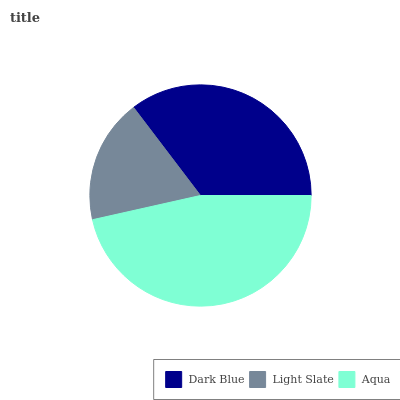Is Light Slate the minimum?
Answer yes or no. Yes. Is Aqua the maximum?
Answer yes or no. Yes. Is Aqua the minimum?
Answer yes or no. No. Is Light Slate the maximum?
Answer yes or no. No. Is Aqua greater than Light Slate?
Answer yes or no. Yes. Is Light Slate less than Aqua?
Answer yes or no. Yes. Is Light Slate greater than Aqua?
Answer yes or no. No. Is Aqua less than Light Slate?
Answer yes or no. No. Is Dark Blue the high median?
Answer yes or no. Yes. Is Dark Blue the low median?
Answer yes or no. Yes. Is Aqua the high median?
Answer yes or no. No. Is Light Slate the low median?
Answer yes or no. No. 